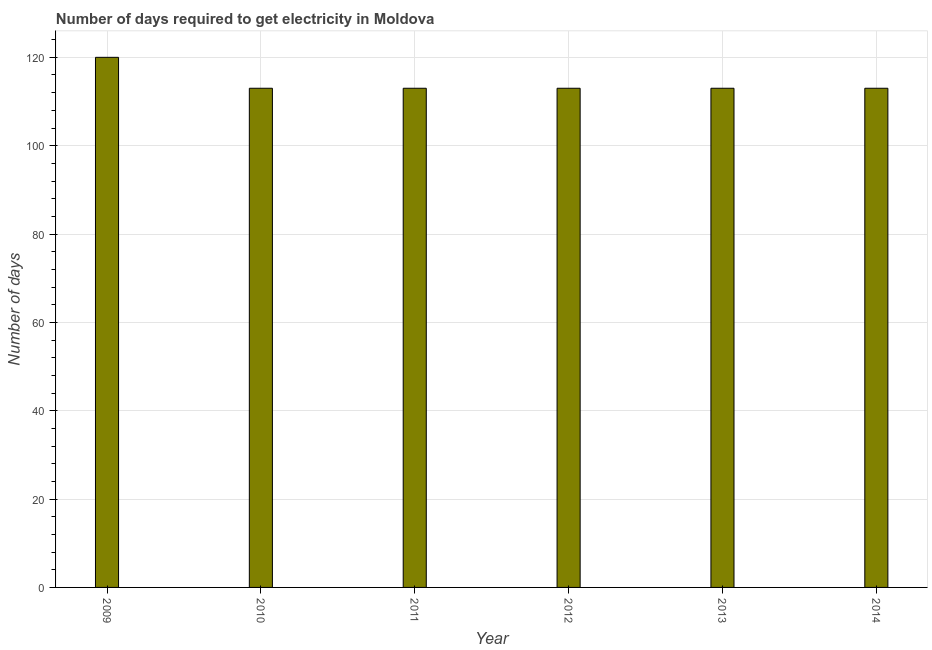Does the graph contain grids?
Your response must be concise. Yes. What is the title of the graph?
Your answer should be compact. Number of days required to get electricity in Moldova. What is the label or title of the X-axis?
Keep it short and to the point. Year. What is the label or title of the Y-axis?
Your response must be concise. Number of days. What is the time to get electricity in 2014?
Your answer should be very brief. 113. Across all years, what is the maximum time to get electricity?
Give a very brief answer. 120. Across all years, what is the minimum time to get electricity?
Your response must be concise. 113. In which year was the time to get electricity maximum?
Keep it short and to the point. 2009. In which year was the time to get electricity minimum?
Your answer should be compact. 2010. What is the sum of the time to get electricity?
Your answer should be compact. 685. What is the difference between the time to get electricity in 2011 and 2013?
Provide a succinct answer. 0. What is the average time to get electricity per year?
Offer a terse response. 114. What is the median time to get electricity?
Ensure brevity in your answer.  113. In how many years, is the time to get electricity greater than 56 ?
Offer a terse response. 6. What is the ratio of the time to get electricity in 2011 to that in 2013?
Offer a very short reply. 1. Is the time to get electricity in 2011 less than that in 2012?
Your answer should be compact. No. What is the difference between the highest and the second highest time to get electricity?
Offer a very short reply. 7. Is the sum of the time to get electricity in 2011 and 2014 greater than the maximum time to get electricity across all years?
Offer a terse response. Yes. What is the difference between the highest and the lowest time to get electricity?
Make the answer very short. 7. What is the difference between two consecutive major ticks on the Y-axis?
Keep it short and to the point. 20. Are the values on the major ticks of Y-axis written in scientific E-notation?
Make the answer very short. No. What is the Number of days of 2009?
Your response must be concise. 120. What is the Number of days in 2010?
Give a very brief answer. 113. What is the Number of days in 2011?
Your response must be concise. 113. What is the Number of days of 2012?
Provide a succinct answer. 113. What is the Number of days of 2013?
Make the answer very short. 113. What is the Number of days of 2014?
Give a very brief answer. 113. What is the difference between the Number of days in 2009 and 2010?
Your response must be concise. 7. What is the difference between the Number of days in 2009 and 2011?
Make the answer very short. 7. What is the difference between the Number of days in 2009 and 2012?
Offer a very short reply. 7. What is the difference between the Number of days in 2009 and 2013?
Provide a short and direct response. 7. What is the difference between the Number of days in 2009 and 2014?
Offer a very short reply. 7. What is the difference between the Number of days in 2010 and 2013?
Provide a short and direct response. 0. What is the difference between the Number of days in 2010 and 2014?
Provide a succinct answer. 0. What is the difference between the Number of days in 2011 and 2013?
Provide a succinct answer. 0. What is the difference between the Number of days in 2012 and 2013?
Give a very brief answer. 0. What is the difference between the Number of days in 2012 and 2014?
Your answer should be compact. 0. What is the difference between the Number of days in 2013 and 2014?
Your answer should be compact. 0. What is the ratio of the Number of days in 2009 to that in 2010?
Keep it short and to the point. 1.06. What is the ratio of the Number of days in 2009 to that in 2011?
Offer a very short reply. 1.06. What is the ratio of the Number of days in 2009 to that in 2012?
Your answer should be compact. 1.06. What is the ratio of the Number of days in 2009 to that in 2013?
Make the answer very short. 1.06. What is the ratio of the Number of days in 2009 to that in 2014?
Your answer should be very brief. 1.06. What is the ratio of the Number of days in 2010 to that in 2012?
Provide a short and direct response. 1. What is the ratio of the Number of days in 2010 to that in 2014?
Provide a succinct answer. 1. What is the ratio of the Number of days in 2011 to that in 2014?
Give a very brief answer. 1. What is the ratio of the Number of days in 2012 to that in 2014?
Make the answer very short. 1. 